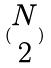Convert formula to latex. <formula><loc_0><loc_0><loc_500><loc_500>( \begin{matrix} N \\ 2 \end{matrix} )</formula> 